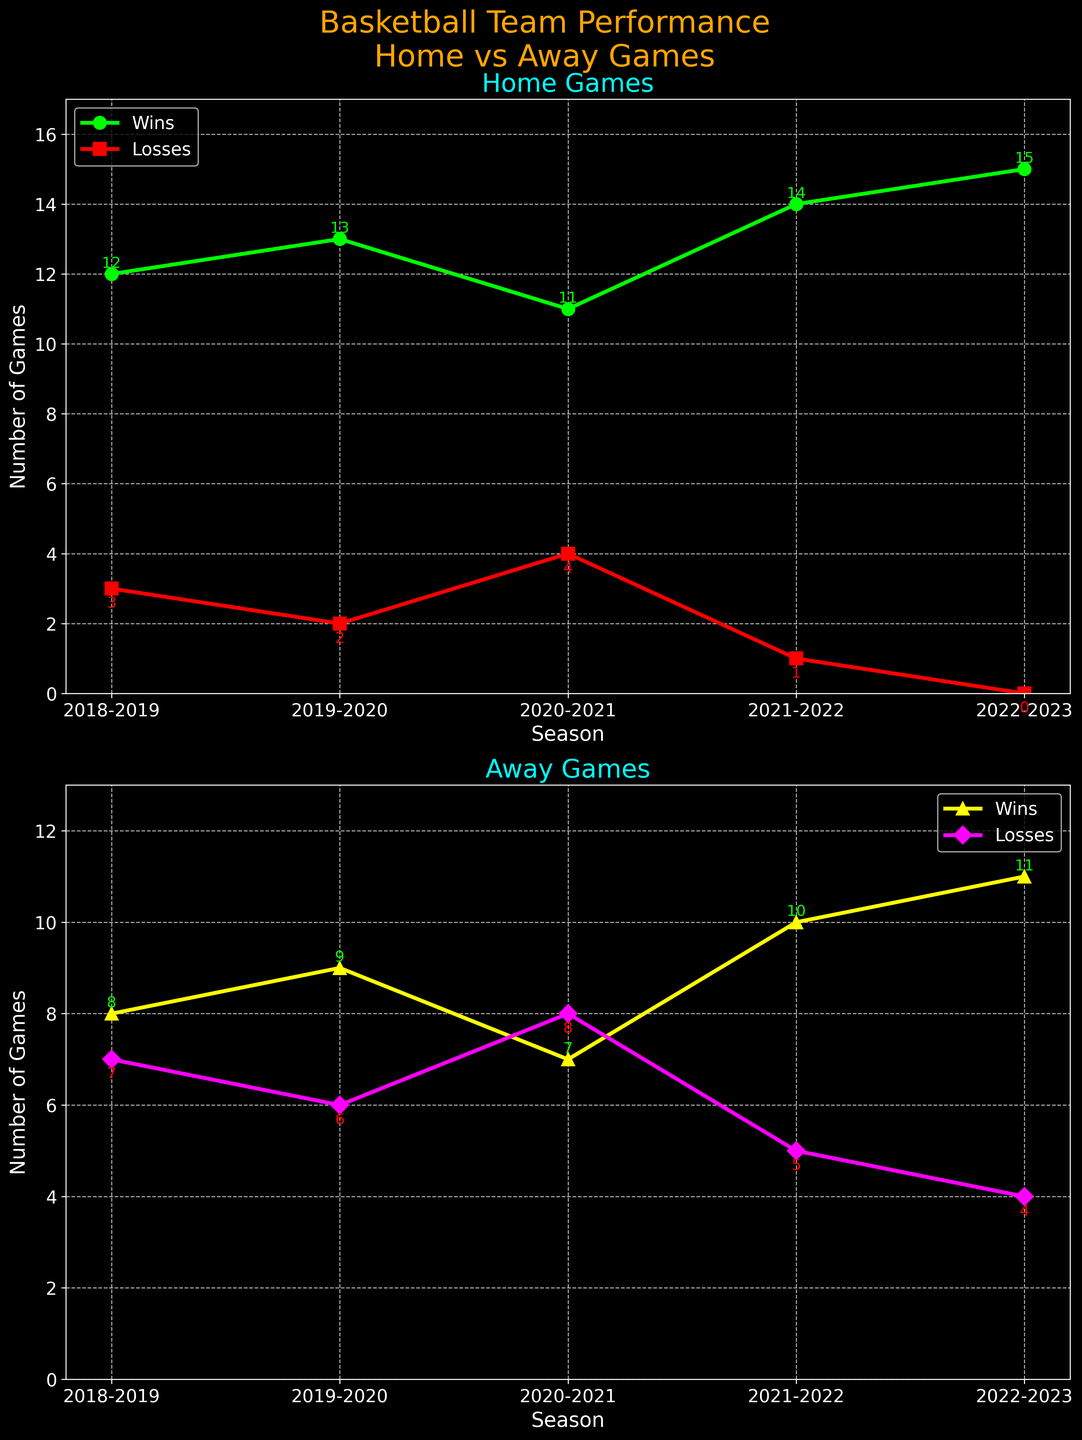What's the title of the top subplot? The title of the top subplot is written directly above it. Refer to the top subplot which focuses on Home Games.
Answer: Home Games How many home wins did the team have in the 2019-2020 season? Look for the "Wins" line in the Home Games subplot and find its value for the 2019-2020 season. The datasets for each season are annotated on the plot.
Answer: 13 Which season had the fewest home losses? Check each season's home losses in the Home Games subplot and identify the lowest value.
Answer: 2022-2023 Did the team improve in away wins over the given seasons? Analyze the trend of the "Wins" line in the Away Games subplot from 2018-2019 to 2022-2023.
Answer: Yes What is the total number of home wins and losses for the 2021-2022 season? Add the home wins and losses for 2021-2022 from the Home Games subplot.
Answer: 14 + 1 = 15 What is the average number of away wins over all seasons? Add all away wins and divide by the number of seasons (5).
Answer: (8 + 9 + 7 + 10 + 11) / 5 = 9 Compare the total number of wins between home and away games for the 2022-2023 season. Which is higher and by how much? Find the wins for both home and away games in 2022-2023 and calculate the difference.
Answer: Home wins are higher by 4 (15 - 11) In which season did the team match its home wins with its away wins? Compare home and away wins for each season in respective subplots to see if any season has equal wins.
Answer: No season Which subplot shows a greater variation in losses over the seasons? Assess the range of losses in both subplots by checking the distance between highest and lowest losses for home and away games.
Answer: Away Games Is there any season when both home and away losses were the highest compared to other seasons? Check the maximum loss values for both home and away games across all seasons and see if any seasons coincide.
Answer: No 